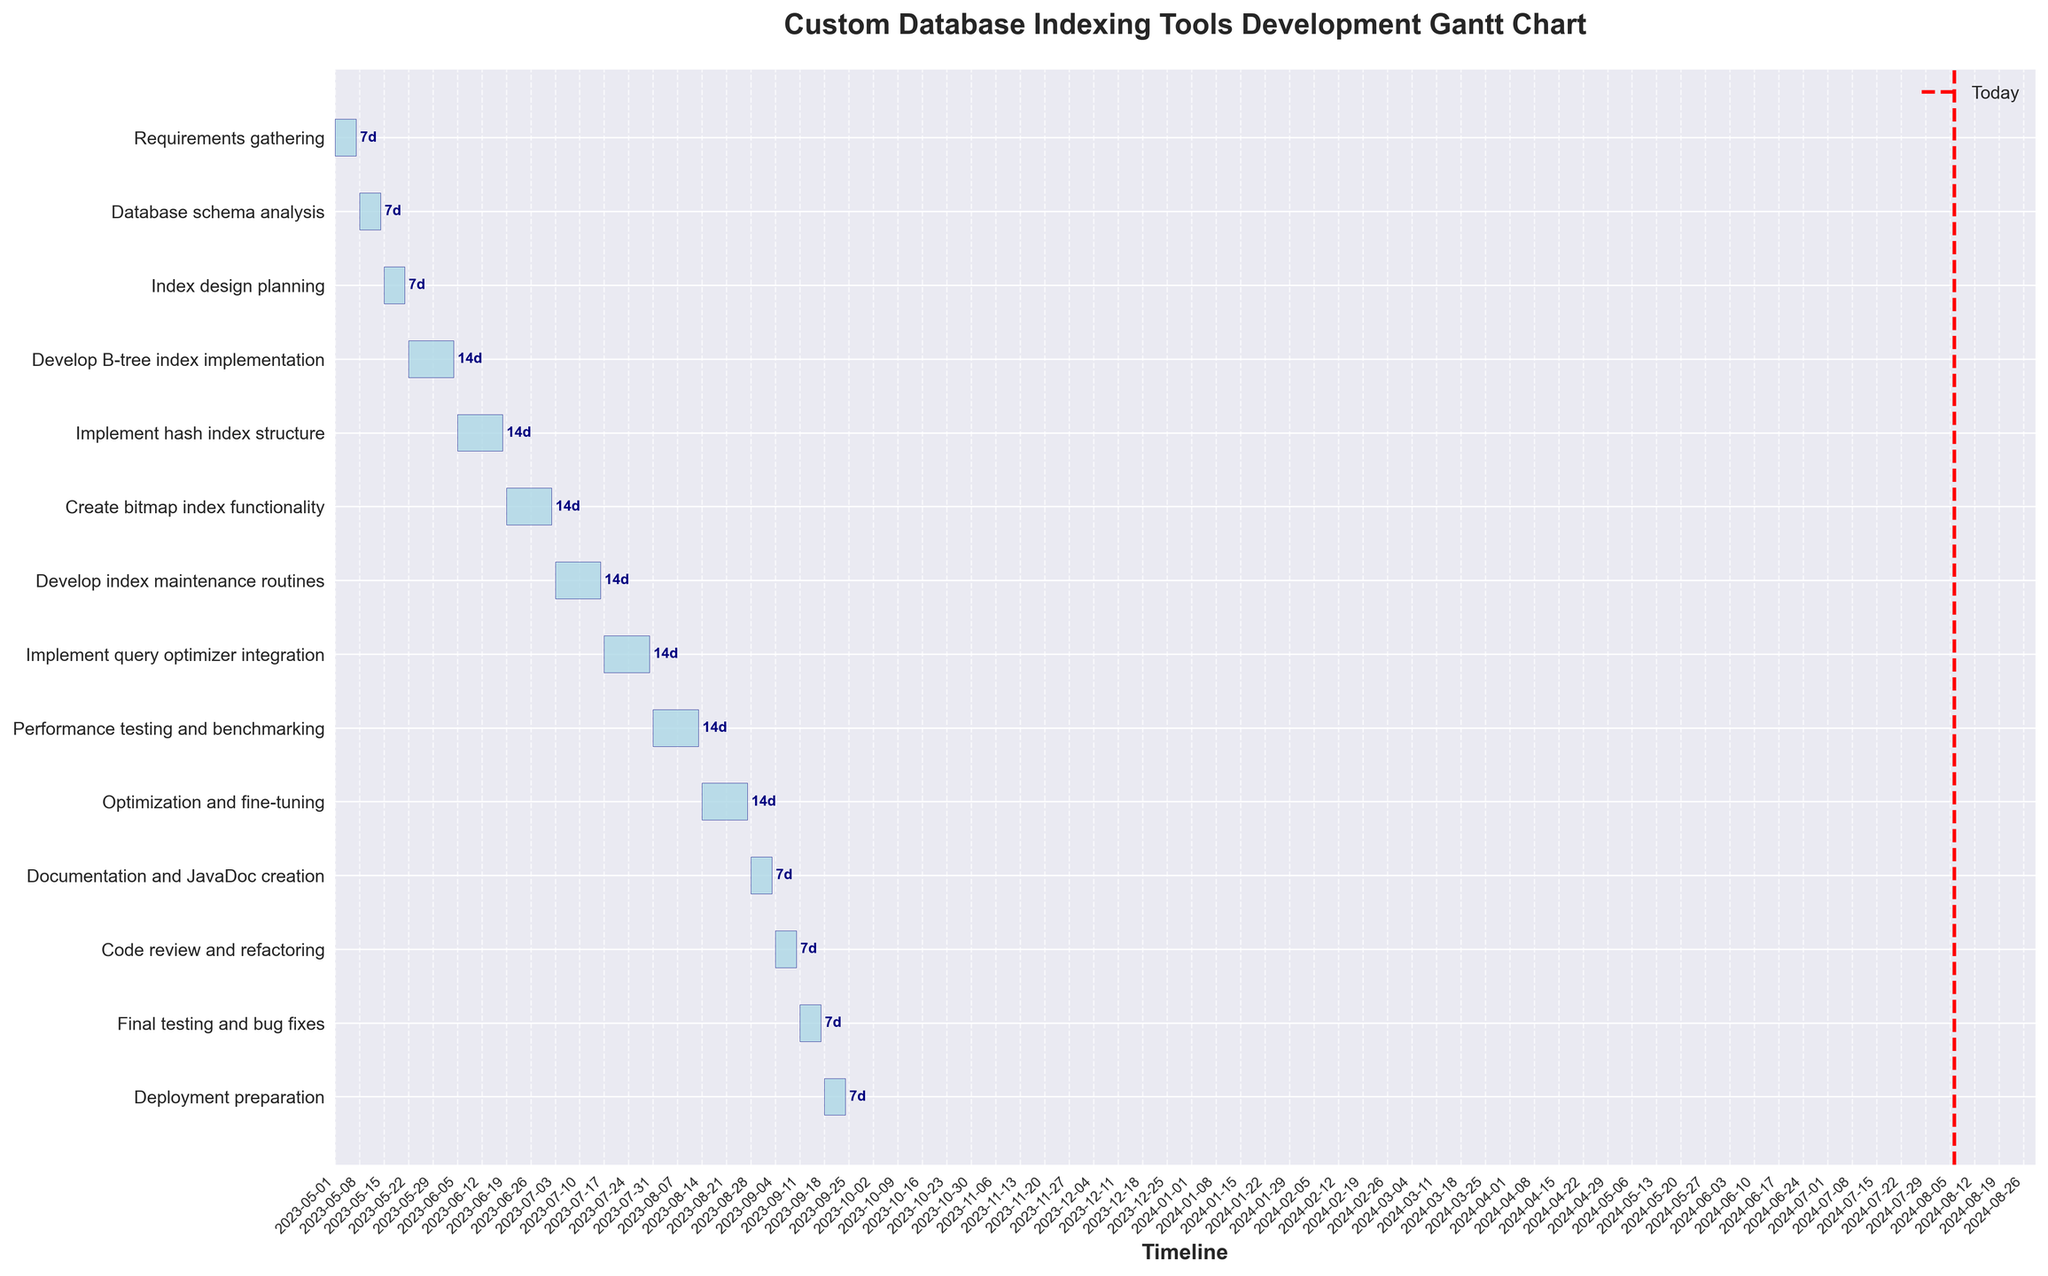What is the title of the Gantt Chart? The title is normally found at the top of the chart. In this case, it is specified in the plot generation code. The title is "Custom Database Indexing Tools Development Gantt Chart".
Answer: Custom Database Indexing Tools Development Gantt Chart Which task has the longest duration? To find the task with the longest duration, look at the horizontal bars and determine which one extends the farthest. "Develop B-tree index implementation" has a duration of 14 days, and several other tasks also have this duration. However, "Develop B-tree index implementation" appears first on the list of 14-day tasks.
Answer: Develop B-tree index implementation How many tasks are scheduled to end after August 1st, 2023? Examine the end date of each task and count how many finish after August 1st, 2023. Based on the Gantt Chart, "Optimization and fine-tuning", "Documentation and JavaDoc creation", "Code review and refactoring", "Final testing and bug fixes", and "Deployment preparation" end after August 1st, 2023.
Answer: 5 What task is scheduled to start immediately after "Database schema analysis"? Look at the start dates and identify which task starts on the next date after the end of "Database schema analysis". The "Index design planning" starts immediately after "Database schema analysis" ends.
Answer: Index design planning Compare the duration of "Develop B-tree index implementation" and "Final testing and bug fixes". Which one is longer? Check the duration of both tasks: "Develop B-tree index implementation" is 14 days, and "Final testing and bug fixes" is 7 days. Thus, "Develop B-tree index implementation" is longer.
Answer: Develop B-tree index implementation What is the total time span from the start of the first task to the end of the last task? Determine the start date of the first task ("Requirements gathering") and the end date of the last task ("Deployment preparation"). Calculate the difference between "2023-05-01" and "2023-09-24". There's 146 days between these two dates.
Answer: 146 days Which task has the shortest duration? Examine the durations listed next to each bar, looking for the smallest number. Tasks like "Requirements gathering", "Documentation and JavaDoc creation", "Code review and refactoring", and "Final testing and bug fixes" all have the shortest duration of 7 days.
Answer: Requirements gathering, Documentation and JavaDoc creation, Code review and refactoring, Final testing and bug fixes How many tasks span more than one week (7 days)? Look at the durations of each task and count those that are more than 7 days. The tasks with durations of 14 days are multiple, specifically, there are 9 tasks of 14 days each.
Answer: 9 Which task overlaps with "Optimization and fine-tuning"? Locate "Optimization and fine-tuning" on the Gantt chart and see which other tasks share the same time period. "Optimization and fine-tuning" overlaps with "Performance testing and benchmarking".
Answer: Performance testing and benchmarking 